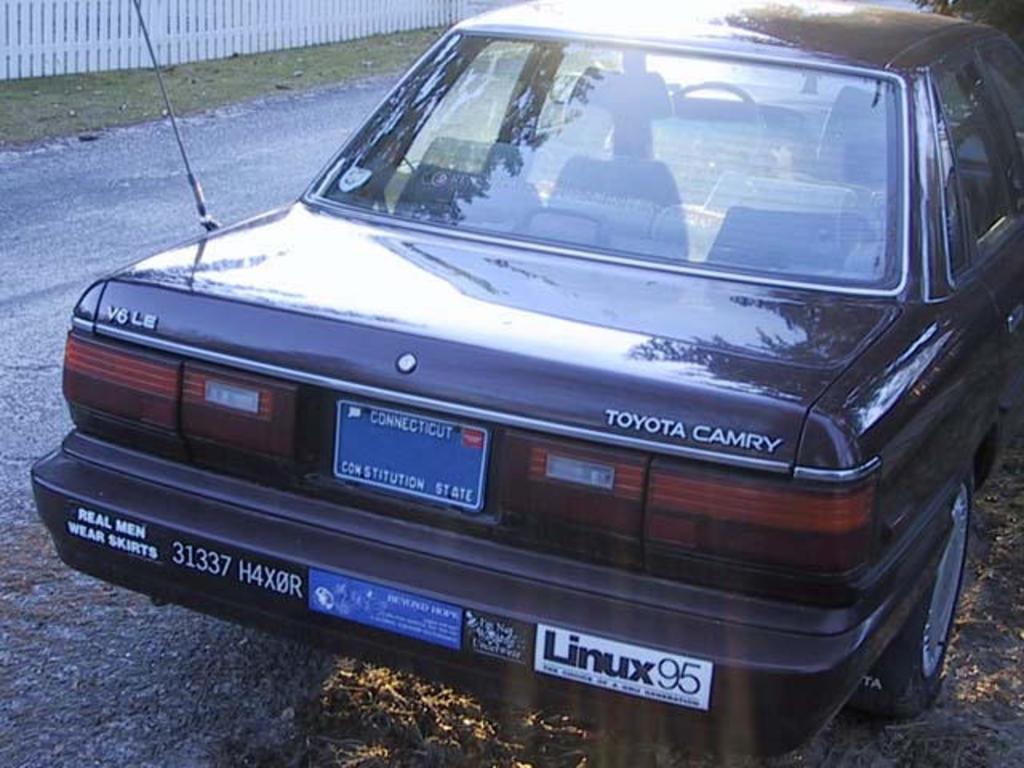How would you summarize this image in a sentence or two? In this picture I can observe a car on the side of the road. In the background I can observe white color railing. 